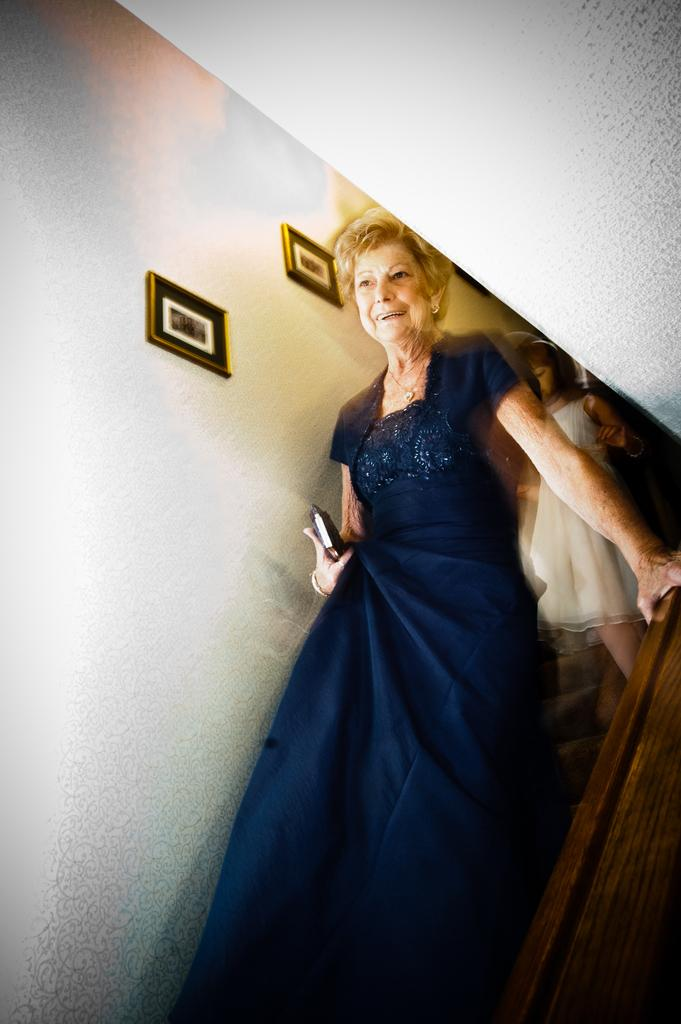Who is present in the image? There is a lady and a kid in the image. What are the lady and the kid doing in the image? The lady and the kid are walking down the steps. What can be seen in the background of the image? There is a wall in the image, and it has photos on it. What type of plantation can be seen in the image? There is no plantation present in the image. 